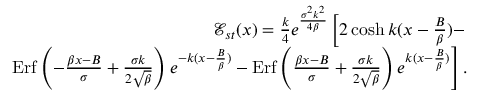<formula> <loc_0><loc_0><loc_500><loc_500>\begin{array} { r l r } & { { \mathcal { E } } _ { s t } ( x ) = \frac { k } { 4 } e ^ { \frac { \sigma ^ { 2 } k ^ { 2 } } { 4 \beta } } \left [ 2 \cosh k ( x - \frac { B } { \beta } ) - } \\ & { E r f \left ( - \frac { \beta x - B } { \sigma } + \frac { \sigma k } { 2 \sqrt { \beta } } \right ) e ^ { - k ( x - \frac { B } { \beta } ) } - E r f \left ( \frac { \beta x - B } { \sigma } + \frac { \sigma k } { 2 \sqrt { \beta } } \right ) e ^ { k ( x - \frac { B } { \beta } ) } \right ] . } \end{array}</formula> 